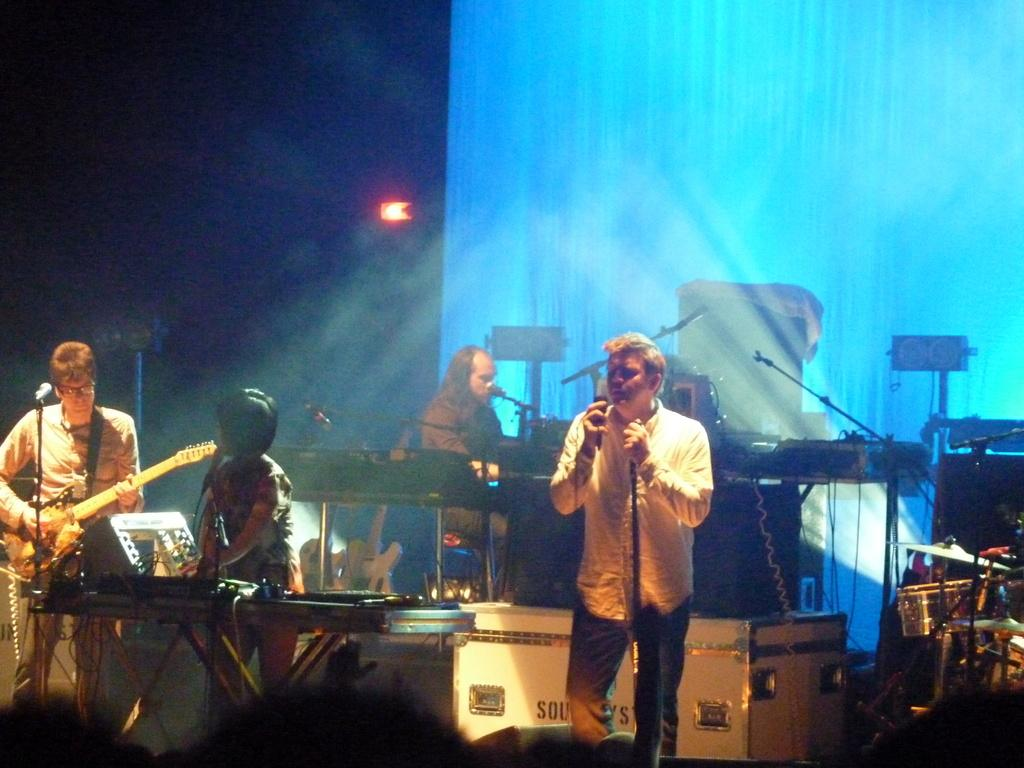How many people are present in the image? There are four people in the image. What are two of the people doing in the image? Two of the people are singing. What are the other two people doing in the image? Two of the people are playing guitars. What can be observed about the background of the image? The background of the image is dark. What type of base is used to support the creator in the image? There is no creator or base present in the image. How does the digestion process of the people in the image affect their performance? There is no information about the digestion process of the people in the image, and it does not affect their performance. 